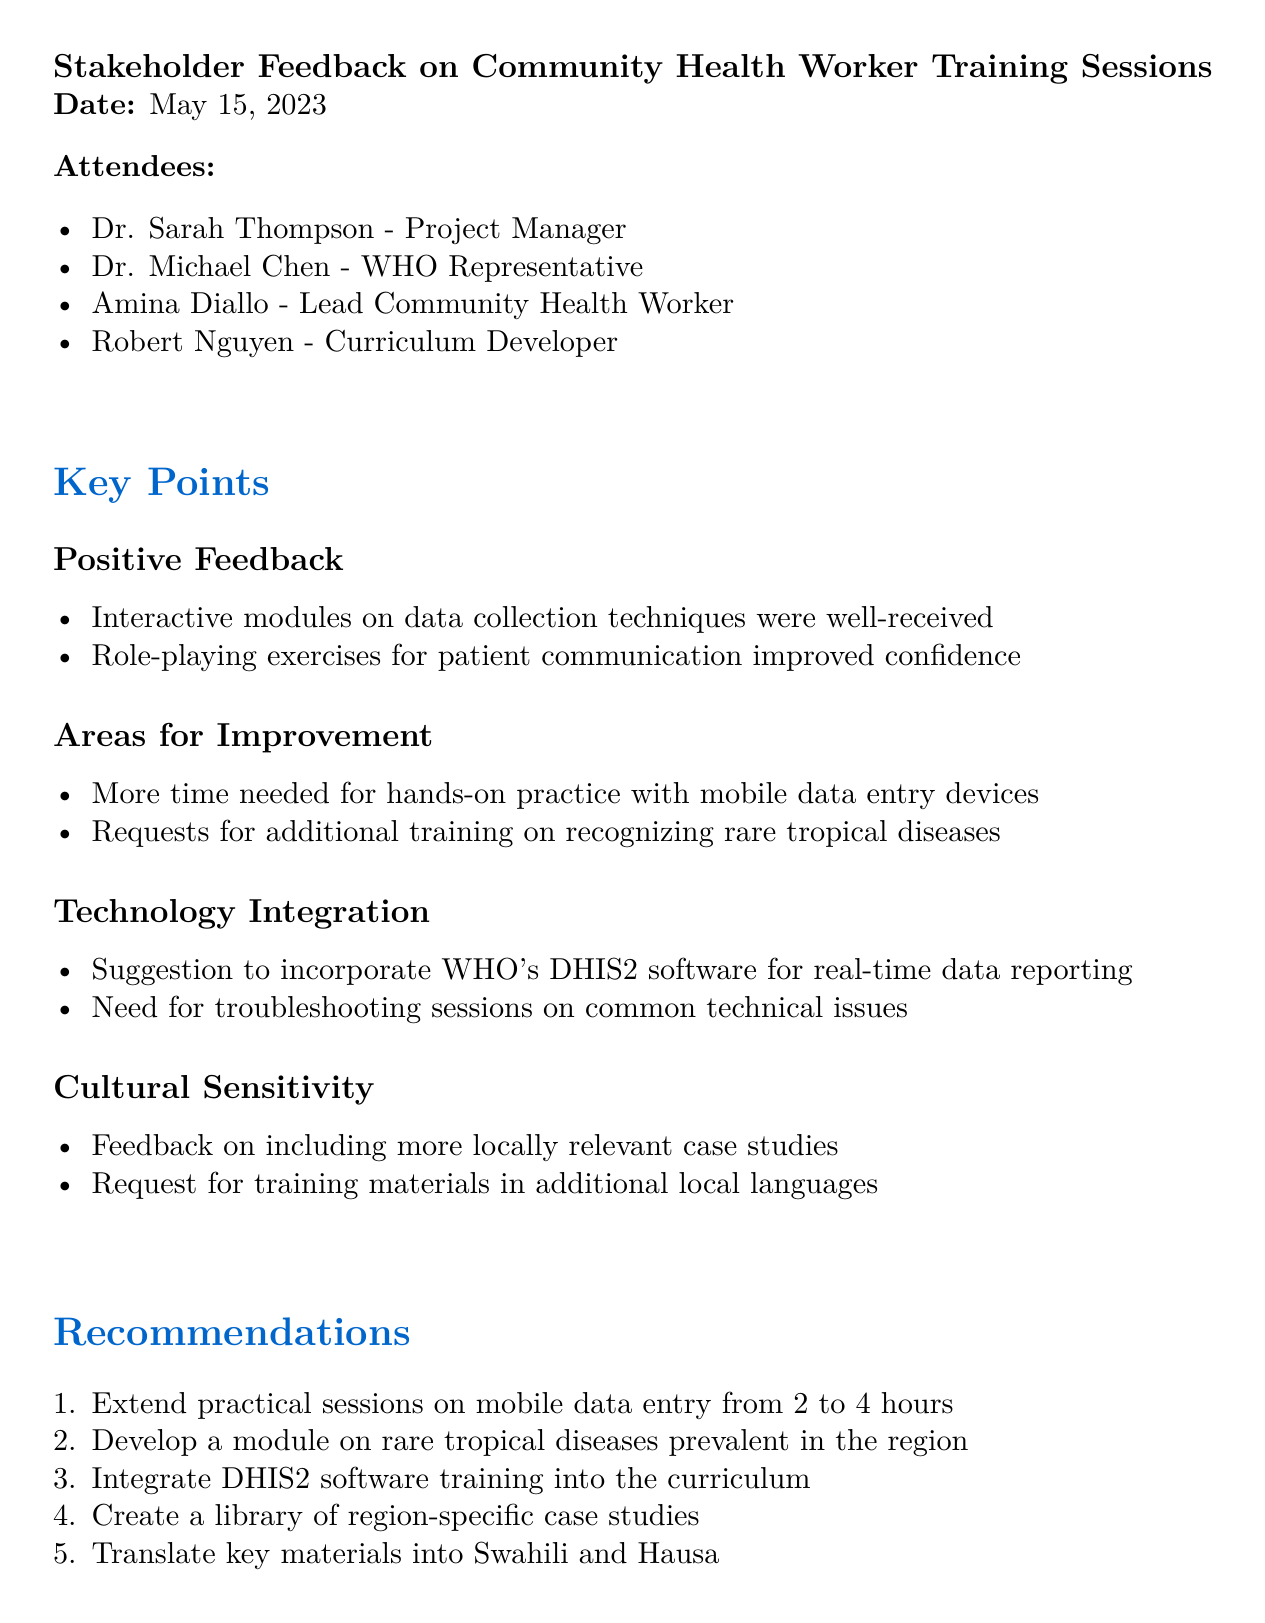What was the date of the meeting? The date of the meeting is stated at the beginning of the document.
Answer: May 15, 2023 Who attended the meeting as the Lead Community Health Worker? The attendees section lists the individuals present at the meeting.
Answer: Amina Diallo What is one area identified for improvement in the training? Areas for improvement are listed in the document, citing specific feedback.
Answer: More time needed for hands-on practice with mobile data entry devices How many recommendations are provided in total? The recommendations section contains a numbered list of suggestions made during the meeting.
Answer: Five Which software was suggested for integration into the curriculum? The technology integration section mentions specific software that was recommended.
Answer: DHIS2 What is one of the next steps mentioned after the meeting? The next steps section outlines specific actions to be taken following the meeting.
Answer: Curriculum team to revise training schedule by June 1st What type of feedback was received regarding cultural sensitivity? Feedback related to cultural sensitivity is highlighted in its own section according to the document structure.
Answer: Request for training materials in additional local languages What was the purpose of the meeting as indicated in the title? The meeting title provides context for the discussions that took place.
Answer: Stakeholder Feedback on Community Health Worker Training Sessions What specific session extension was recommended? The recommendations list details a specific change to the duration of a training session.
Answer: Extend practical sessions on mobile data entry from 2 to 4 hours 